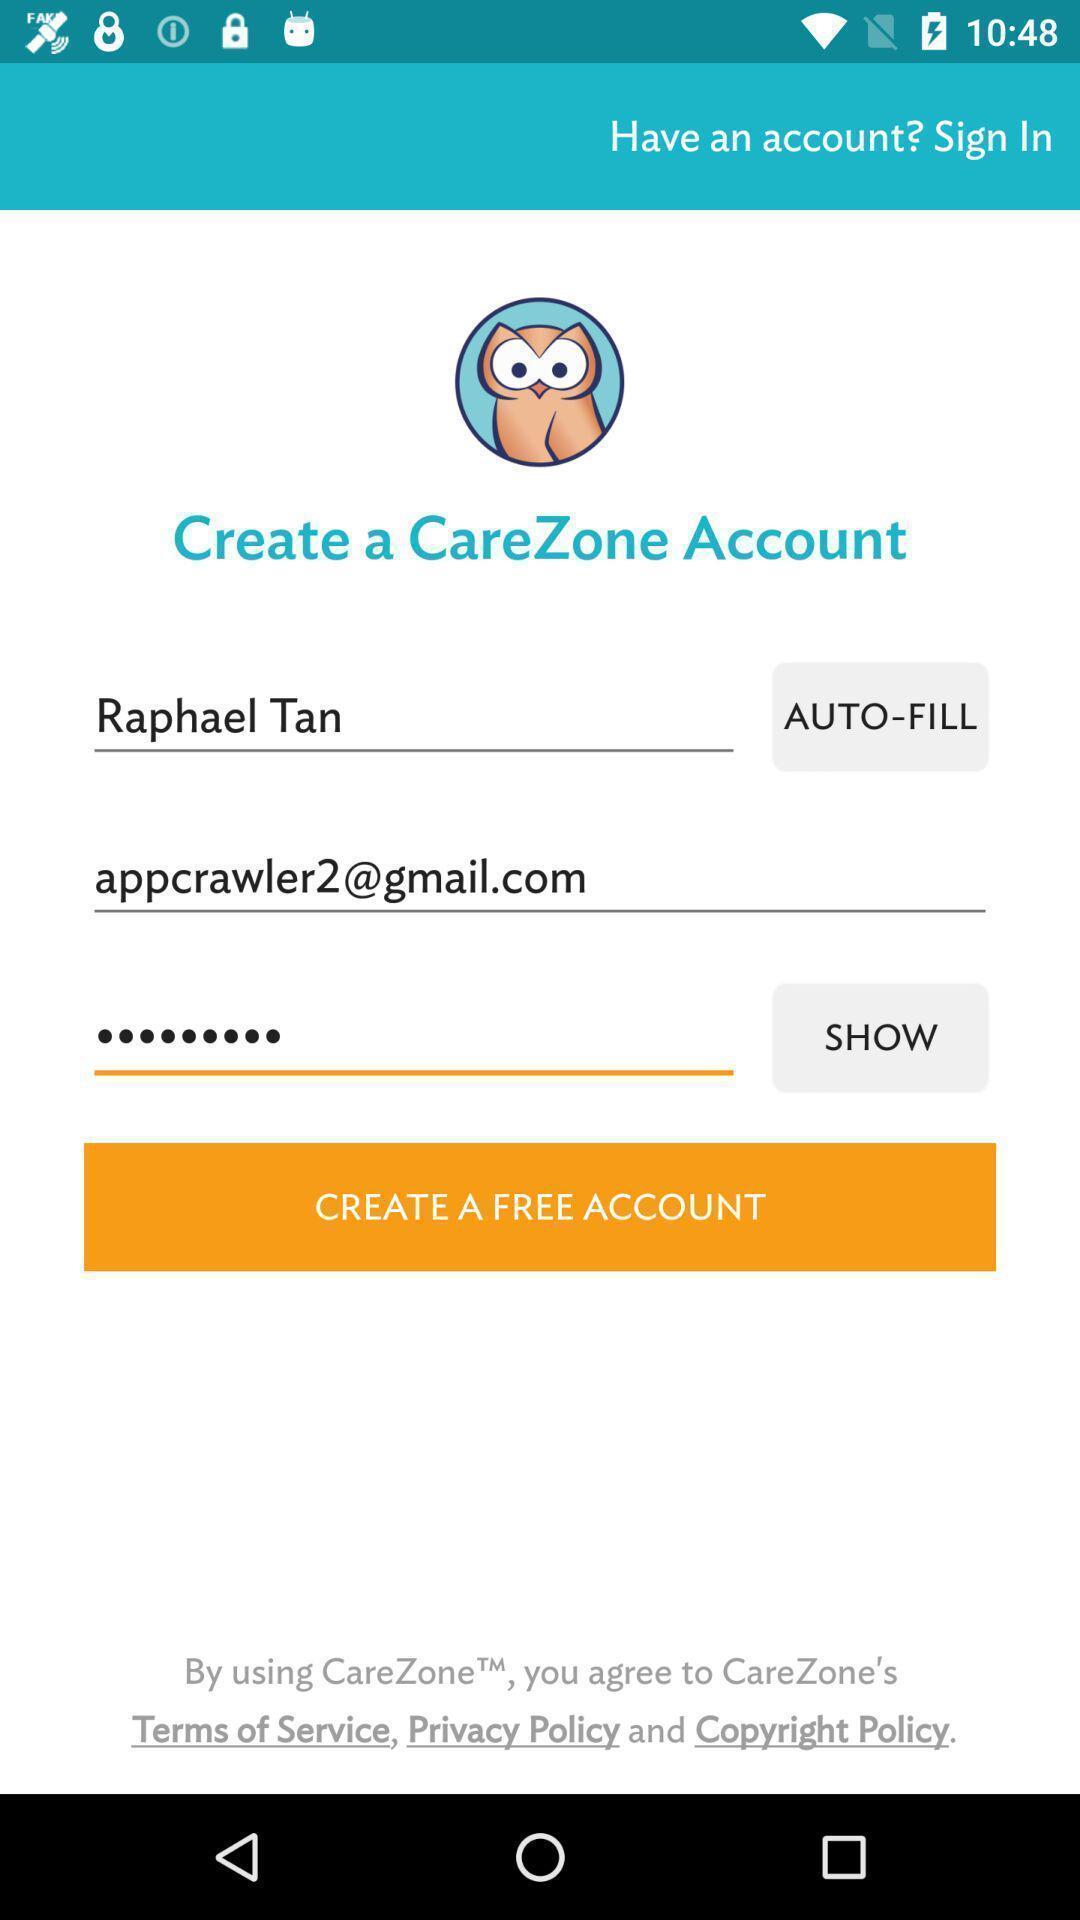Please provide a description for this image. Screen showing create account page. 